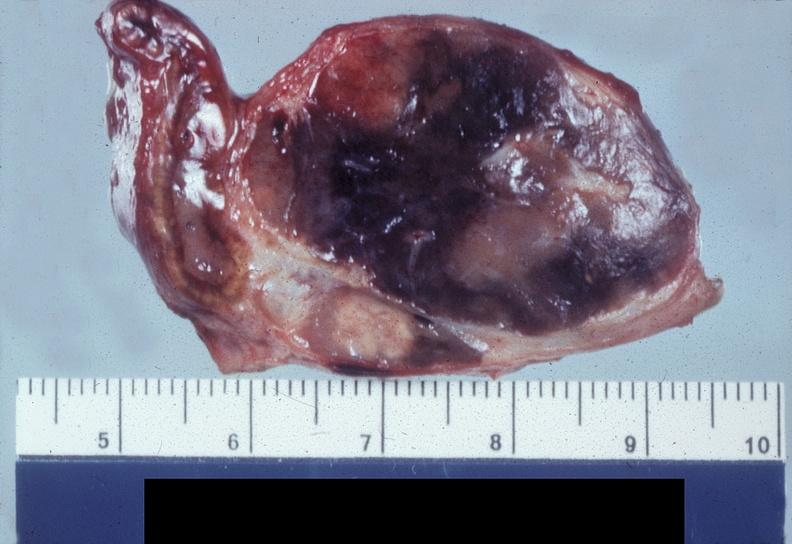does this image show adrenal, pheochromocytoma?
Answer the question using a single word or phrase. Yes 